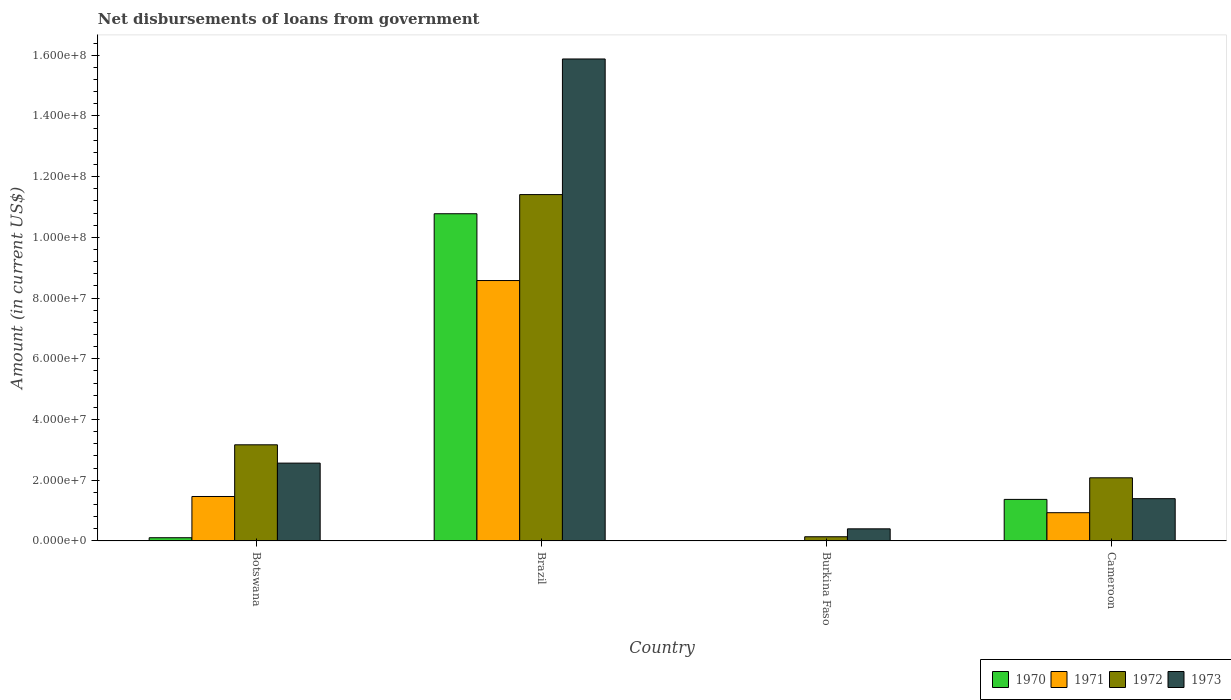How many different coloured bars are there?
Provide a short and direct response. 4. How many groups of bars are there?
Your answer should be very brief. 4. Are the number of bars on each tick of the X-axis equal?
Give a very brief answer. No. How many bars are there on the 2nd tick from the left?
Your answer should be compact. 4. What is the label of the 3rd group of bars from the left?
Keep it short and to the point. Burkina Faso. What is the amount of loan disbursed from government in 1972 in Cameroon?
Make the answer very short. 2.08e+07. Across all countries, what is the maximum amount of loan disbursed from government in 1970?
Make the answer very short. 1.08e+08. Across all countries, what is the minimum amount of loan disbursed from government in 1971?
Your answer should be compact. 0. What is the total amount of loan disbursed from government in 1971 in the graph?
Provide a succinct answer. 1.10e+08. What is the difference between the amount of loan disbursed from government in 1970 in Brazil and that in Burkina Faso?
Offer a terse response. 1.08e+08. What is the difference between the amount of loan disbursed from government in 1970 in Brazil and the amount of loan disbursed from government in 1971 in Botswana?
Provide a short and direct response. 9.31e+07. What is the average amount of loan disbursed from government in 1973 per country?
Provide a short and direct response. 5.06e+07. What is the difference between the amount of loan disbursed from government of/in 1970 and amount of loan disbursed from government of/in 1973 in Burkina Faso?
Ensure brevity in your answer.  -3.86e+06. What is the ratio of the amount of loan disbursed from government in 1973 in Botswana to that in Burkina Faso?
Offer a very short reply. 6.43. Is the amount of loan disbursed from government in 1970 in Burkina Faso less than that in Cameroon?
Your answer should be compact. Yes. What is the difference between the highest and the second highest amount of loan disbursed from government in 1971?
Provide a succinct answer. 7.11e+07. What is the difference between the highest and the lowest amount of loan disbursed from government in 1971?
Your answer should be very brief. 8.58e+07. Is it the case that in every country, the sum of the amount of loan disbursed from government in 1972 and amount of loan disbursed from government in 1971 is greater than the sum of amount of loan disbursed from government in 1970 and amount of loan disbursed from government in 1973?
Give a very brief answer. No. How many bars are there?
Give a very brief answer. 15. How many countries are there in the graph?
Provide a succinct answer. 4. Does the graph contain any zero values?
Keep it short and to the point. Yes. Does the graph contain grids?
Give a very brief answer. No. Where does the legend appear in the graph?
Provide a short and direct response. Bottom right. How many legend labels are there?
Provide a short and direct response. 4. How are the legend labels stacked?
Offer a very short reply. Horizontal. What is the title of the graph?
Offer a terse response. Net disbursements of loans from government. Does "1999" appear as one of the legend labels in the graph?
Offer a very short reply. No. What is the Amount (in current US$) in 1970 in Botswana?
Provide a succinct answer. 1.06e+06. What is the Amount (in current US$) of 1971 in Botswana?
Provide a short and direct response. 1.46e+07. What is the Amount (in current US$) in 1972 in Botswana?
Provide a succinct answer. 3.17e+07. What is the Amount (in current US$) in 1973 in Botswana?
Ensure brevity in your answer.  2.56e+07. What is the Amount (in current US$) of 1970 in Brazil?
Provide a succinct answer. 1.08e+08. What is the Amount (in current US$) of 1971 in Brazil?
Your response must be concise. 8.58e+07. What is the Amount (in current US$) in 1972 in Brazil?
Offer a terse response. 1.14e+08. What is the Amount (in current US$) in 1973 in Brazil?
Your response must be concise. 1.59e+08. What is the Amount (in current US$) in 1970 in Burkina Faso?
Your answer should be compact. 1.29e+05. What is the Amount (in current US$) of 1971 in Burkina Faso?
Your answer should be compact. 0. What is the Amount (in current US$) of 1972 in Burkina Faso?
Provide a succinct answer. 1.38e+06. What is the Amount (in current US$) of 1973 in Burkina Faso?
Give a very brief answer. 3.98e+06. What is the Amount (in current US$) in 1970 in Cameroon?
Keep it short and to the point. 1.37e+07. What is the Amount (in current US$) of 1971 in Cameroon?
Give a very brief answer. 9.30e+06. What is the Amount (in current US$) of 1972 in Cameroon?
Give a very brief answer. 2.08e+07. What is the Amount (in current US$) in 1973 in Cameroon?
Your answer should be very brief. 1.39e+07. Across all countries, what is the maximum Amount (in current US$) in 1970?
Ensure brevity in your answer.  1.08e+08. Across all countries, what is the maximum Amount (in current US$) in 1971?
Offer a very short reply. 8.58e+07. Across all countries, what is the maximum Amount (in current US$) of 1972?
Your answer should be very brief. 1.14e+08. Across all countries, what is the maximum Amount (in current US$) in 1973?
Provide a short and direct response. 1.59e+08. Across all countries, what is the minimum Amount (in current US$) of 1970?
Provide a short and direct response. 1.29e+05. Across all countries, what is the minimum Amount (in current US$) of 1971?
Your response must be concise. 0. Across all countries, what is the minimum Amount (in current US$) in 1972?
Offer a very short reply. 1.38e+06. Across all countries, what is the minimum Amount (in current US$) in 1973?
Your answer should be very brief. 3.98e+06. What is the total Amount (in current US$) in 1970 in the graph?
Your answer should be compact. 1.23e+08. What is the total Amount (in current US$) of 1971 in the graph?
Offer a terse response. 1.10e+08. What is the total Amount (in current US$) in 1972 in the graph?
Ensure brevity in your answer.  1.68e+08. What is the total Amount (in current US$) of 1973 in the graph?
Your answer should be compact. 2.02e+08. What is the difference between the Amount (in current US$) of 1970 in Botswana and that in Brazil?
Offer a terse response. -1.07e+08. What is the difference between the Amount (in current US$) in 1971 in Botswana and that in Brazil?
Your answer should be compact. -7.11e+07. What is the difference between the Amount (in current US$) in 1972 in Botswana and that in Brazil?
Offer a very short reply. -8.24e+07. What is the difference between the Amount (in current US$) of 1973 in Botswana and that in Brazil?
Provide a succinct answer. -1.33e+08. What is the difference between the Amount (in current US$) in 1970 in Botswana and that in Burkina Faso?
Your answer should be very brief. 9.28e+05. What is the difference between the Amount (in current US$) in 1972 in Botswana and that in Burkina Faso?
Your answer should be very brief. 3.03e+07. What is the difference between the Amount (in current US$) of 1973 in Botswana and that in Burkina Faso?
Ensure brevity in your answer.  2.17e+07. What is the difference between the Amount (in current US$) of 1970 in Botswana and that in Cameroon?
Offer a very short reply. -1.26e+07. What is the difference between the Amount (in current US$) of 1971 in Botswana and that in Cameroon?
Keep it short and to the point. 5.34e+06. What is the difference between the Amount (in current US$) of 1972 in Botswana and that in Cameroon?
Provide a succinct answer. 1.09e+07. What is the difference between the Amount (in current US$) in 1973 in Botswana and that in Cameroon?
Provide a short and direct response. 1.17e+07. What is the difference between the Amount (in current US$) of 1970 in Brazil and that in Burkina Faso?
Keep it short and to the point. 1.08e+08. What is the difference between the Amount (in current US$) of 1972 in Brazil and that in Burkina Faso?
Ensure brevity in your answer.  1.13e+08. What is the difference between the Amount (in current US$) in 1973 in Brazil and that in Burkina Faso?
Provide a short and direct response. 1.55e+08. What is the difference between the Amount (in current US$) in 1970 in Brazil and that in Cameroon?
Make the answer very short. 9.41e+07. What is the difference between the Amount (in current US$) of 1971 in Brazil and that in Cameroon?
Ensure brevity in your answer.  7.65e+07. What is the difference between the Amount (in current US$) in 1972 in Brazil and that in Cameroon?
Offer a terse response. 9.33e+07. What is the difference between the Amount (in current US$) in 1973 in Brazil and that in Cameroon?
Make the answer very short. 1.45e+08. What is the difference between the Amount (in current US$) of 1970 in Burkina Faso and that in Cameroon?
Give a very brief answer. -1.36e+07. What is the difference between the Amount (in current US$) in 1972 in Burkina Faso and that in Cameroon?
Provide a short and direct response. -1.94e+07. What is the difference between the Amount (in current US$) of 1973 in Burkina Faso and that in Cameroon?
Keep it short and to the point. -9.94e+06. What is the difference between the Amount (in current US$) of 1970 in Botswana and the Amount (in current US$) of 1971 in Brazil?
Make the answer very short. -8.47e+07. What is the difference between the Amount (in current US$) in 1970 in Botswana and the Amount (in current US$) in 1972 in Brazil?
Your answer should be compact. -1.13e+08. What is the difference between the Amount (in current US$) in 1970 in Botswana and the Amount (in current US$) in 1973 in Brazil?
Keep it short and to the point. -1.58e+08. What is the difference between the Amount (in current US$) in 1971 in Botswana and the Amount (in current US$) in 1972 in Brazil?
Ensure brevity in your answer.  -9.95e+07. What is the difference between the Amount (in current US$) in 1971 in Botswana and the Amount (in current US$) in 1973 in Brazil?
Offer a terse response. -1.44e+08. What is the difference between the Amount (in current US$) of 1972 in Botswana and the Amount (in current US$) of 1973 in Brazil?
Ensure brevity in your answer.  -1.27e+08. What is the difference between the Amount (in current US$) of 1970 in Botswana and the Amount (in current US$) of 1972 in Burkina Faso?
Offer a terse response. -3.23e+05. What is the difference between the Amount (in current US$) in 1970 in Botswana and the Amount (in current US$) in 1973 in Burkina Faso?
Provide a short and direct response. -2.93e+06. What is the difference between the Amount (in current US$) in 1971 in Botswana and the Amount (in current US$) in 1972 in Burkina Faso?
Offer a terse response. 1.33e+07. What is the difference between the Amount (in current US$) of 1971 in Botswana and the Amount (in current US$) of 1973 in Burkina Faso?
Keep it short and to the point. 1.07e+07. What is the difference between the Amount (in current US$) in 1972 in Botswana and the Amount (in current US$) in 1973 in Burkina Faso?
Keep it short and to the point. 2.77e+07. What is the difference between the Amount (in current US$) in 1970 in Botswana and the Amount (in current US$) in 1971 in Cameroon?
Provide a short and direct response. -8.24e+06. What is the difference between the Amount (in current US$) in 1970 in Botswana and the Amount (in current US$) in 1972 in Cameroon?
Make the answer very short. -1.97e+07. What is the difference between the Amount (in current US$) of 1970 in Botswana and the Amount (in current US$) of 1973 in Cameroon?
Give a very brief answer. -1.29e+07. What is the difference between the Amount (in current US$) in 1971 in Botswana and the Amount (in current US$) in 1972 in Cameroon?
Give a very brief answer. -6.16e+06. What is the difference between the Amount (in current US$) of 1971 in Botswana and the Amount (in current US$) of 1973 in Cameroon?
Provide a succinct answer. 7.14e+05. What is the difference between the Amount (in current US$) of 1972 in Botswana and the Amount (in current US$) of 1973 in Cameroon?
Offer a very short reply. 1.77e+07. What is the difference between the Amount (in current US$) of 1970 in Brazil and the Amount (in current US$) of 1972 in Burkina Faso?
Give a very brief answer. 1.06e+08. What is the difference between the Amount (in current US$) in 1970 in Brazil and the Amount (in current US$) in 1973 in Burkina Faso?
Ensure brevity in your answer.  1.04e+08. What is the difference between the Amount (in current US$) in 1971 in Brazil and the Amount (in current US$) in 1972 in Burkina Faso?
Make the answer very short. 8.44e+07. What is the difference between the Amount (in current US$) in 1971 in Brazil and the Amount (in current US$) in 1973 in Burkina Faso?
Make the answer very short. 8.18e+07. What is the difference between the Amount (in current US$) of 1972 in Brazil and the Amount (in current US$) of 1973 in Burkina Faso?
Offer a very short reply. 1.10e+08. What is the difference between the Amount (in current US$) in 1970 in Brazil and the Amount (in current US$) in 1971 in Cameroon?
Keep it short and to the point. 9.85e+07. What is the difference between the Amount (in current US$) in 1970 in Brazil and the Amount (in current US$) in 1972 in Cameroon?
Your response must be concise. 8.70e+07. What is the difference between the Amount (in current US$) of 1970 in Brazil and the Amount (in current US$) of 1973 in Cameroon?
Provide a short and direct response. 9.39e+07. What is the difference between the Amount (in current US$) in 1971 in Brazil and the Amount (in current US$) in 1972 in Cameroon?
Keep it short and to the point. 6.50e+07. What is the difference between the Amount (in current US$) of 1971 in Brazil and the Amount (in current US$) of 1973 in Cameroon?
Make the answer very short. 7.18e+07. What is the difference between the Amount (in current US$) of 1972 in Brazil and the Amount (in current US$) of 1973 in Cameroon?
Make the answer very short. 1.00e+08. What is the difference between the Amount (in current US$) in 1970 in Burkina Faso and the Amount (in current US$) in 1971 in Cameroon?
Give a very brief answer. -9.17e+06. What is the difference between the Amount (in current US$) of 1970 in Burkina Faso and the Amount (in current US$) of 1972 in Cameroon?
Your answer should be very brief. -2.07e+07. What is the difference between the Amount (in current US$) in 1970 in Burkina Faso and the Amount (in current US$) in 1973 in Cameroon?
Ensure brevity in your answer.  -1.38e+07. What is the difference between the Amount (in current US$) of 1972 in Burkina Faso and the Amount (in current US$) of 1973 in Cameroon?
Provide a short and direct response. -1.25e+07. What is the average Amount (in current US$) of 1970 per country?
Ensure brevity in your answer.  3.07e+07. What is the average Amount (in current US$) in 1971 per country?
Provide a succinct answer. 2.74e+07. What is the average Amount (in current US$) in 1972 per country?
Your answer should be very brief. 4.20e+07. What is the average Amount (in current US$) in 1973 per country?
Ensure brevity in your answer.  5.06e+07. What is the difference between the Amount (in current US$) of 1970 and Amount (in current US$) of 1971 in Botswana?
Make the answer very short. -1.36e+07. What is the difference between the Amount (in current US$) of 1970 and Amount (in current US$) of 1972 in Botswana?
Your answer should be very brief. -3.06e+07. What is the difference between the Amount (in current US$) of 1970 and Amount (in current US$) of 1973 in Botswana?
Ensure brevity in your answer.  -2.46e+07. What is the difference between the Amount (in current US$) in 1971 and Amount (in current US$) in 1972 in Botswana?
Keep it short and to the point. -1.70e+07. What is the difference between the Amount (in current US$) in 1971 and Amount (in current US$) in 1973 in Botswana?
Give a very brief answer. -1.10e+07. What is the difference between the Amount (in current US$) in 1972 and Amount (in current US$) in 1973 in Botswana?
Provide a short and direct response. 6.03e+06. What is the difference between the Amount (in current US$) of 1970 and Amount (in current US$) of 1971 in Brazil?
Your response must be concise. 2.20e+07. What is the difference between the Amount (in current US$) of 1970 and Amount (in current US$) of 1972 in Brazil?
Your answer should be compact. -6.31e+06. What is the difference between the Amount (in current US$) of 1970 and Amount (in current US$) of 1973 in Brazil?
Your response must be concise. -5.10e+07. What is the difference between the Amount (in current US$) in 1971 and Amount (in current US$) in 1972 in Brazil?
Offer a terse response. -2.83e+07. What is the difference between the Amount (in current US$) of 1971 and Amount (in current US$) of 1973 in Brazil?
Give a very brief answer. -7.30e+07. What is the difference between the Amount (in current US$) in 1972 and Amount (in current US$) in 1973 in Brazil?
Provide a succinct answer. -4.47e+07. What is the difference between the Amount (in current US$) of 1970 and Amount (in current US$) of 1972 in Burkina Faso?
Offer a very short reply. -1.25e+06. What is the difference between the Amount (in current US$) of 1970 and Amount (in current US$) of 1973 in Burkina Faso?
Provide a succinct answer. -3.86e+06. What is the difference between the Amount (in current US$) of 1972 and Amount (in current US$) of 1973 in Burkina Faso?
Your response must be concise. -2.60e+06. What is the difference between the Amount (in current US$) in 1970 and Amount (in current US$) in 1971 in Cameroon?
Your answer should be very brief. 4.38e+06. What is the difference between the Amount (in current US$) in 1970 and Amount (in current US$) in 1972 in Cameroon?
Offer a terse response. -7.12e+06. What is the difference between the Amount (in current US$) of 1970 and Amount (in current US$) of 1973 in Cameroon?
Keep it short and to the point. -2.45e+05. What is the difference between the Amount (in current US$) in 1971 and Amount (in current US$) in 1972 in Cameroon?
Your answer should be very brief. -1.15e+07. What is the difference between the Amount (in current US$) in 1971 and Amount (in current US$) in 1973 in Cameroon?
Ensure brevity in your answer.  -4.63e+06. What is the difference between the Amount (in current US$) of 1972 and Amount (in current US$) of 1973 in Cameroon?
Make the answer very short. 6.87e+06. What is the ratio of the Amount (in current US$) in 1970 in Botswana to that in Brazil?
Provide a succinct answer. 0.01. What is the ratio of the Amount (in current US$) in 1971 in Botswana to that in Brazil?
Give a very brief answer. 0.17. What is the ratio of the Amount (in current US$) of 1972 in Botswana to that in Brazil?
Ensure brevity in your answer.  0.28. What is the ratio of the Amount (in current US$) of 1973 in Botswana to that in Brazil?
Your answer should be compact. 0.16. What is the ratio of the Amount (in current US$) in 1970 in Botswana to that in Burkina Faso?
Offer a terse response. 8.19. What is the ratio of the Amount (in current US$) of 1972 in Botswana to that in Burkina Faso?
Make the answer very short. 22.95. What is the ratio of the Amount (in current US$) of 1973 in Botswana to that in Burkina Faso?
Make the answer very short. 6.43. What is the ratio of the Amount (in current US$) of 1970 in Botswana to that in Cameroon?
Offer a terse response. 0.08. What is the ratio of the Amount (in current US$) in 1971 in Botswana to that in Cameroon?
Provide a succinct answer. 1.57. What is the ratio of the Amount (in current US$) in 1972 in Botswana to that in Cameroon?
Your answer should be very brief. 1.52. What is the ratio of the Amount (in current US$) in 1973 in Botswana to that in Cameroon?
Offer a very short reply. 1.84. What is the ratio of the Amount (in current US$) in 1970 in Brazil to that in Burkina Faso?
Provide a short and direct response. 835.53. What is the ratio of the Amount (in current US$) in 1972 in Brazil to that in Burkina Faso?
Offer a terse response. 82.68. What is the ratio of the Amount (in current US$) in 1973 in Brazil to that in Burkina Faso?
Provide a short and direct response. 39.84. What is the ratio of the Amount (in current US$) of 1970 in Brazil to that in Cameroon?
Ensure brevity in your answer.  7.88. What is the ratio of the Amount (in current US$) in 1971 in Brazil to that in Cameroon?
Keep it short and to the point. 9.22. What is the ratio of the Amount (in current US$) of 1972 in Brazil to that in Cameroon?
Keep it short and to the point. 5.49. What is the ratio of the Amount (in current US$) in 1973 in Brazil to that in Cameroon?
Make the answer very short. 11.4. What is the ratio of the Amount (in current US$) in 1970 in Burkina Faso to that in Cameroon?
Keep it short and to the point. 0.01. What is the ratio of the Amount (in current US$) of 1972 in Burkina Faso to that in Cameroon?
Keep it short and to the point. 0.07. What is the ratio of the Amount (in current US$) in 1973 in Burkina Faso to that in Cameroon?
Provide a short and direct response. 0.29. What is the difference between the highest and the second highest Amount (in current US$) in 1970?
Make the answer very short. 9.41e+07. What is the difference between the highest and the second highest Amount (in current US$) of 1971?
Your response must be concise. 7.11e+07. What is the difference between the highest and the second highest Amount (in current US$) in 1972?
Offer a terse response. 8.24e+07. What is the difference between the highest and the second highest Amount (in current US$) of 1973?
Provide a short and direct response. 1.33e+08. What is the difference between the highest and the lowest Amount (in current US$) of 1970?
Keep it short and to the point. 1.08e+08. What is the difference between the highest and the lowest Amount (in current US$) in 1971?
Provide a short and direct response. 8.58e+07. What is the difference between the highest and the lowest Amount (in current US$) in 1972?
Make the answer very short. 1.13e+08. What is the difference between the highest and the lowest Amount (in current US$) in 1973?
Make the answer very short. 1.55e+08. 